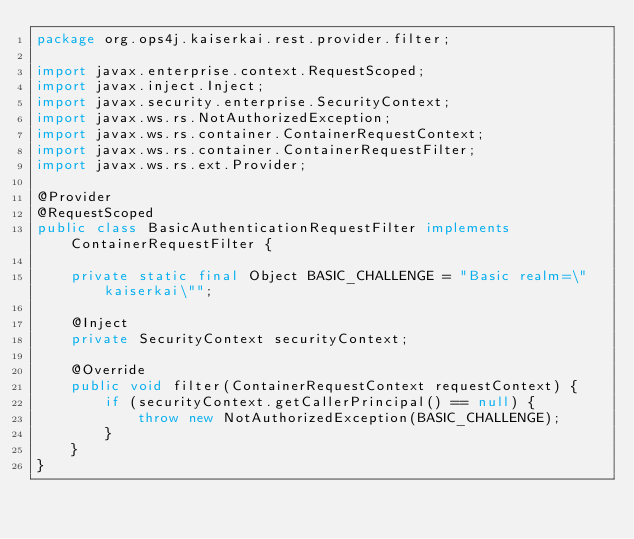<code> <loc_0><loc_0><loc_500><loc_500><_Java_>package org.ops4j.kaiserkai.rest.provider.filter;

import javax.enterprise.context.RequestScoped;
import javax.inject.Inject;
import javax.security.enterprise.SecurityContext;
import javax.ws.rs.NotAuthorizedException;
import javax.ws.rs.container.ContainerRequestContext;
import javax.ws.rs.container.ContainerRequestFilter;
import javax.ws.rs.ext.Provider;

@Provider
@RequestScoped
public class BasicAuthenticationRequestFilter implements ContainerRequestFilter {

    private static final Object BASIC_CHALLENGE = "Basic realm=\"kaiserkai\"";

    @Inject
    private SecurityContext securityContext;

    @Override
    public void filter(ContainerRequestContext requestContext) {
        if (securityContext.getCallerPrincipal() == null) {
            throw new NotAuthorizedException(BASIC_CHALLENGE);
        }
    }
}
</code> 